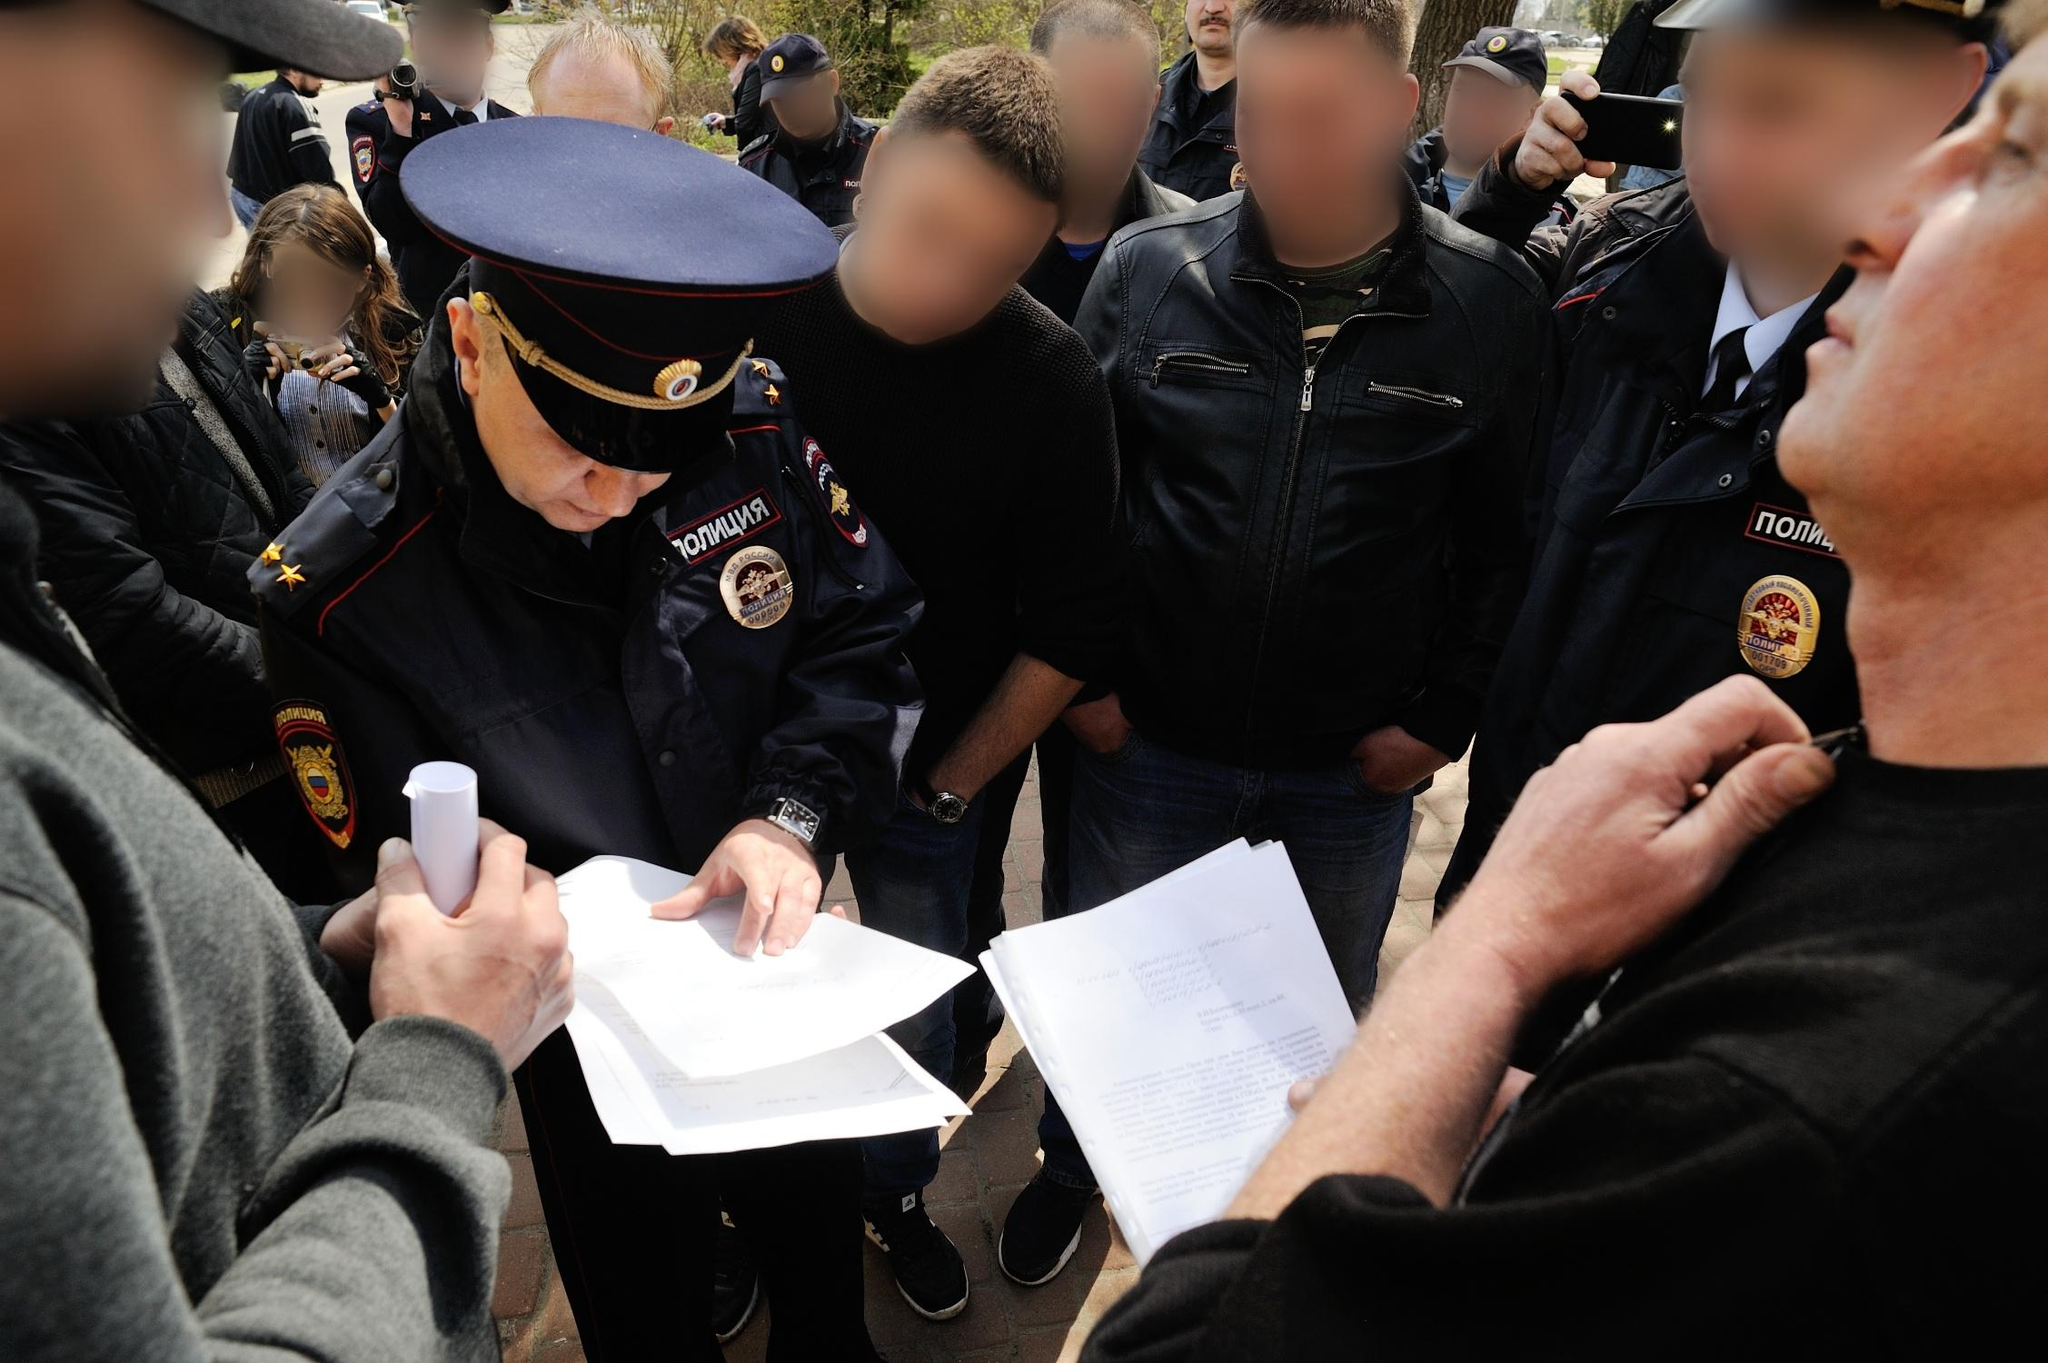Imagine if one of these people were thinking about something completely unrelated, what could it be? In a whimsical twist, one of the individuals might be daydreaming about a fantastical escape—perhaps envisioning themselves soaring through the skies on a dragon, far away from the seriousness of the current situation. They might be picturing lush green landscapes, magical creatures, and ancient castles, as a stark contrast to the officer's stern presence and the gravity of the documents being reviewed. This vivid daydream momentarily transports them away from the public space into a realm of pure fantasy. 